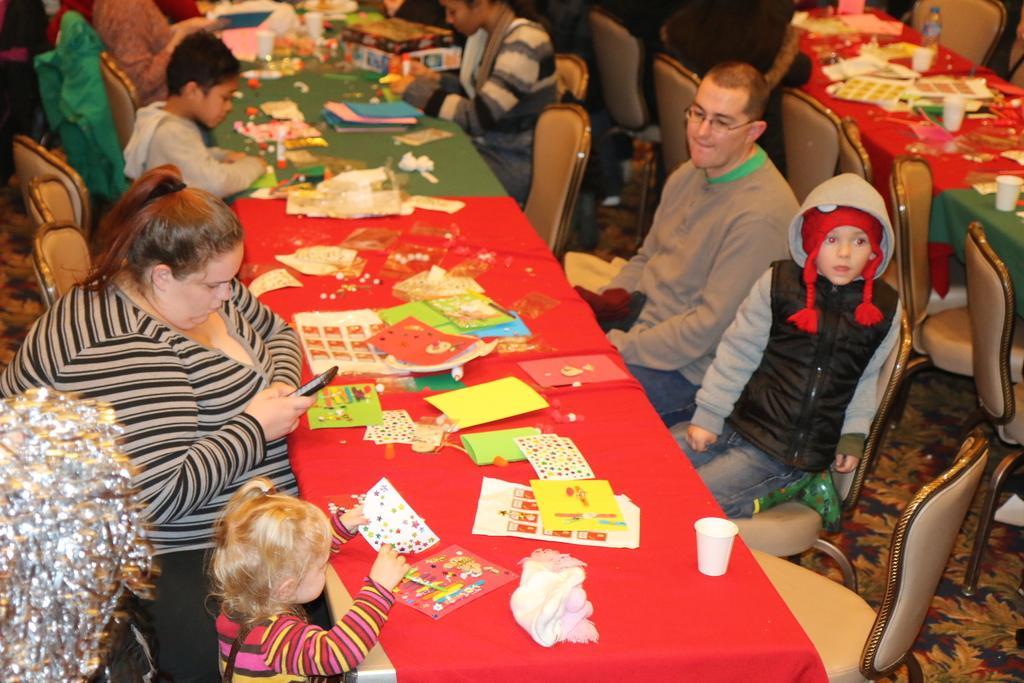In one or two sentences, can you explain what this image depicts? In this picture there are group of people, they are sitting around the tables, and there is a boy at the right side of the image who is seeing to the front direction, it seems to be art and craft activities which is going on in the image. 